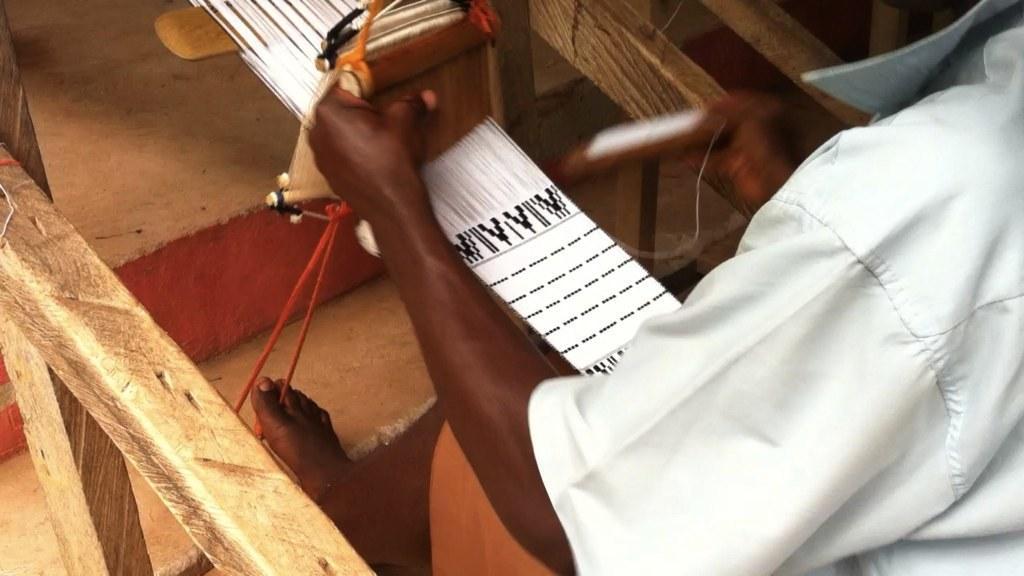Could you give a brief overview of what you see in this image? On the right side, we see a man in the white shirt is sitting and I think he is wearing the clothes. On the left side, we see the wooden objects. At the bottom, we see the stairs. In the background, we see the wooden objects. 